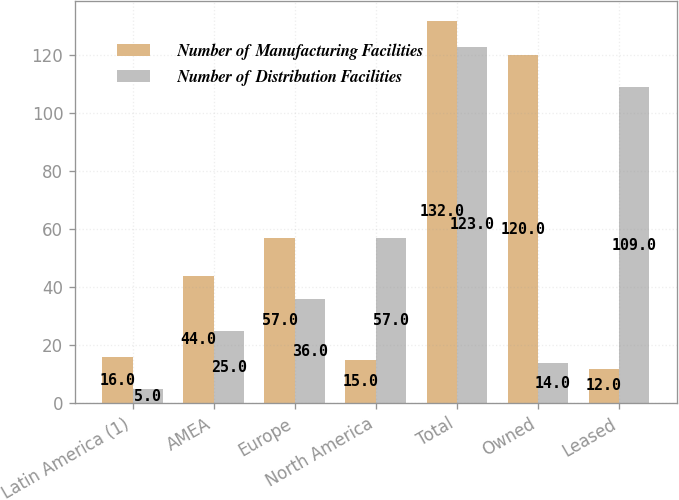<chart> <loc_0><loc_0><loc_500><loc_500><stacked_bar_chart><ecel><fcel>Latin America (1)<fcel>AMEA<fcel>Europe<fcel>North America<fcel>Total<fcel>Owned<fcel>Leased<nl><fcel>Number of Manufacturing Facilities<fcel>16<fcel>44<fcel>57<fcel>15<fcel>132<fcel>120<fcel>12<nl><fcel>Number of Distribution Facilities<fcel>5<fcel>25<fcel>36<fcel>57<fcel>123<fcel>14<fcel>109<nl></chart> 